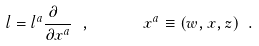Convert formula to latex. <formula><loc_0><loc_0><loc_500><loc_500>l = l ^ { a } \frac { \partial \ } { \partial x ^ { a } } \ , \quad \ \ x ^ { a } \equiv ( w , x , z ) \ .</formula> 